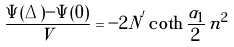<formula> <loc_0><loc_0><loc_500><loc_500>\frac { \Psi ( \Delta ) - \Psi ( 0 ) } { V } = - 2 N ^ { ^ { \prime } } \coth \frac { \alpha _ { 1 } } { 2 } \, \tilde { n } ^ { 2 }</formula> 